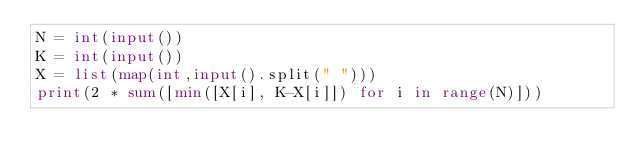Convert code to text. <code><loc_0><loc_0><loc_500><loc_500><_Python_>N = int(input())
K = int(input())
X = list(map(int,input().split(" ")))
print(2 * sum([min([X[i], K-X[i]]) for i in range(N)]))</code> 